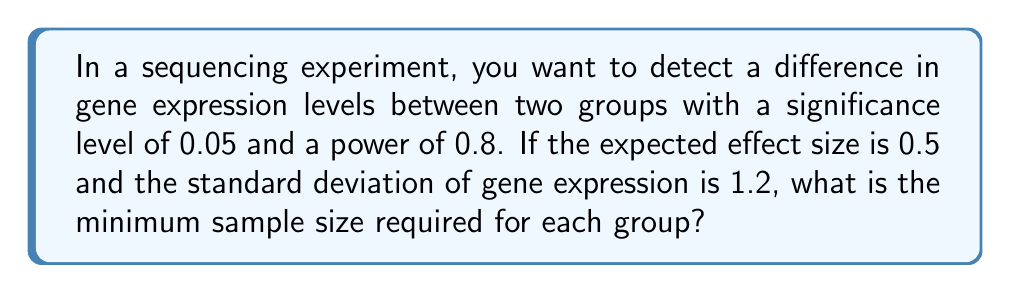Can you solve this math problem? To determine the optimal sample size for a sequencing experiment using power analysis, we'll follow these steps:

1. Define the parameters:
   - Significance level (α) = 0.05
   - Power (1 - β) = 0.8
   - Effect size (d) = 0.5
   - Standard deviation (σ) = 1.2

2. Use the formula for sample size calculation in a two-sample t-test:

   $$ n = \frac{2(z_{1-\alpha/2} + z_{1-\beta})^2\sigma^2}{d^2} $$

   Where:
   - $n$ is the sample size per group
   - $z_{1-\alpha/2}$ is the critical value for the significance level
   - $z_{1-\beta}$ is the critical value for the power

3. Find the critical values:
   - For α = 0.05, $z_{1-\alpha/2} = 1.96$ (two-tailed test)
   - For power = 0.8, $z_{1-\beta} = 0.84$

4. Substitute the values into the formula:

   $$ n = \frac{2(1.96 + 0.84)^2 \cdot 1.2^2}{0.5^2} $$

5. Calculate:
   $$ n = \frac{2(2.8)^2 \cdot 1.44}{0.25} = \frac{2 \cdot 7.84 \cdot 1.44}{0.25} = \frac{22.5792}{0.25} = 90.3168 $$

6. Round up to the nearest whole number:
   $n = 91$

Therefore, the minimum sample size required for each group is 91.
Answer: 91 samples per group 